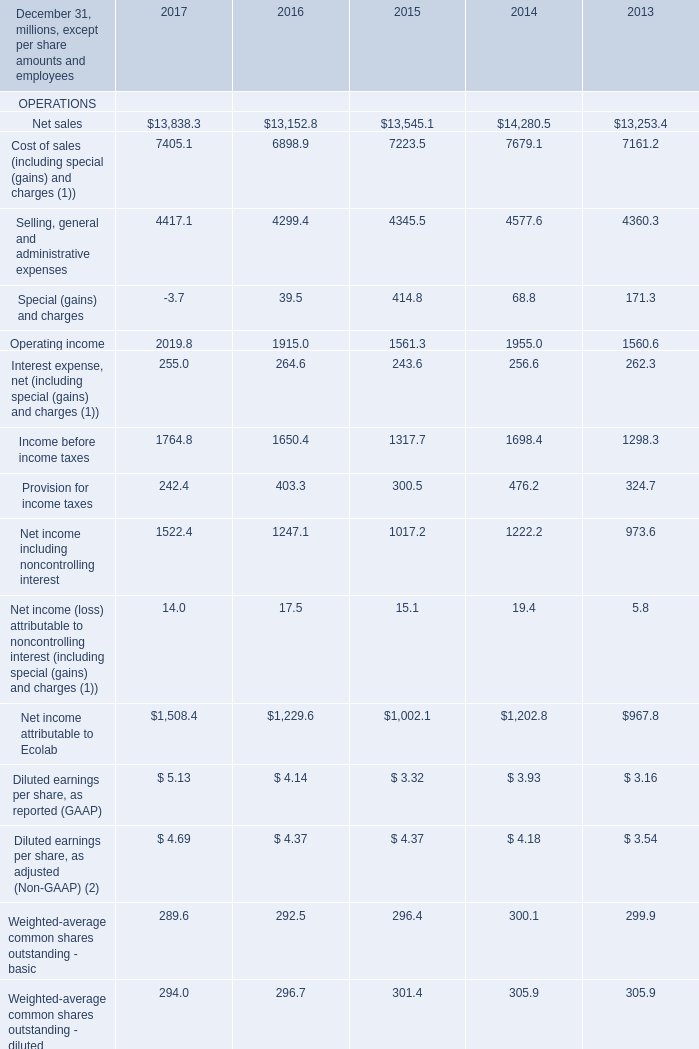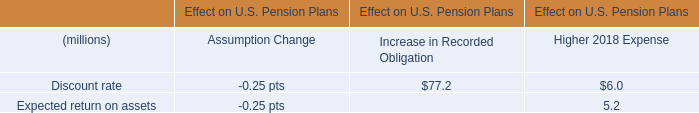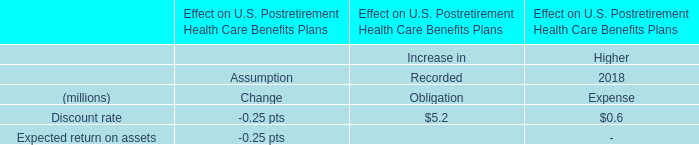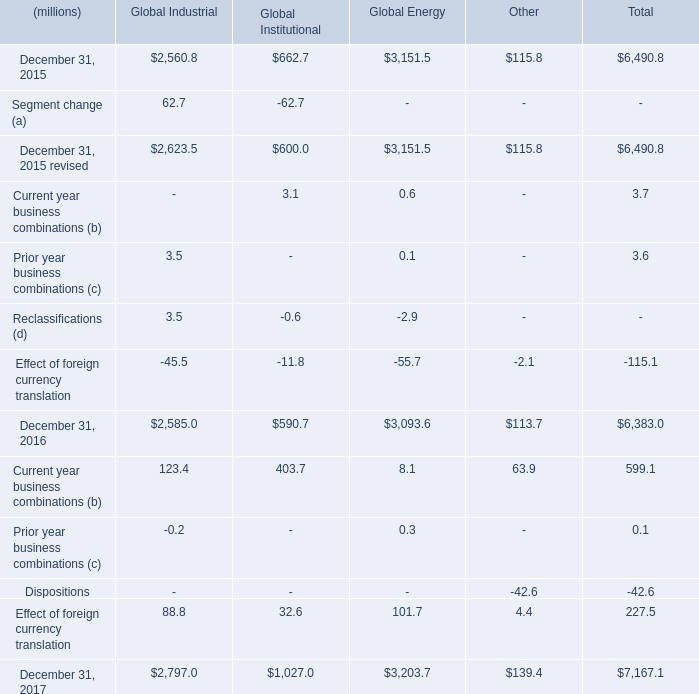Which year is Cost of sales (including special (gains) and charges (1)) the least? 
Answer: 2016. 